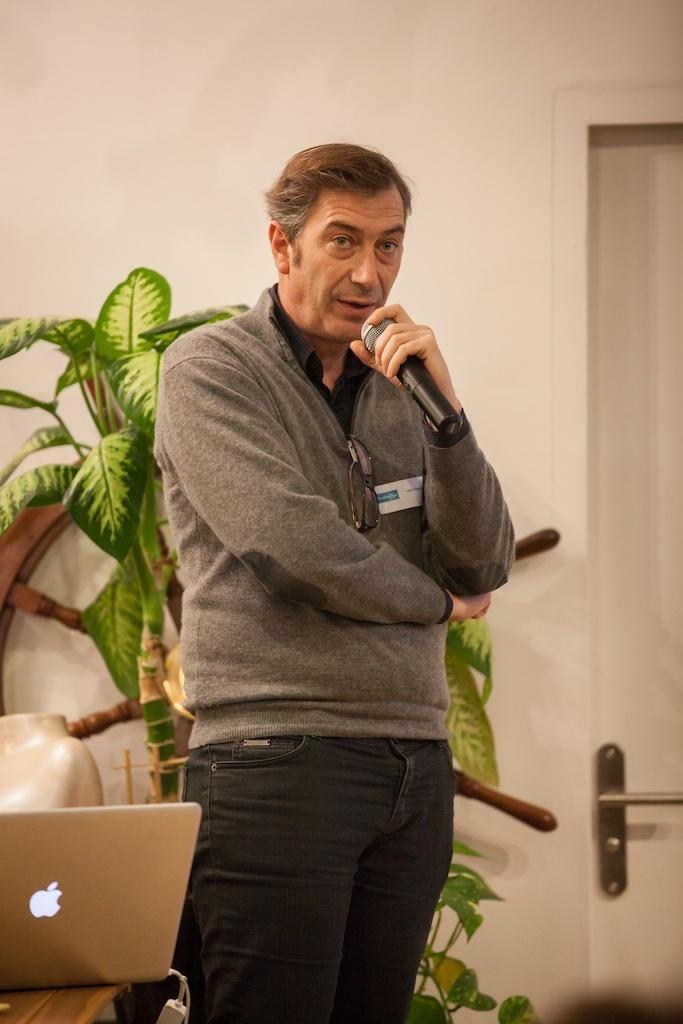Please provide a concise description of this image. In this picture there is a person who is wearing a jacket and holding a mic and standing in front of the table on which there is a laptop and behind him there is a plant and a door. 